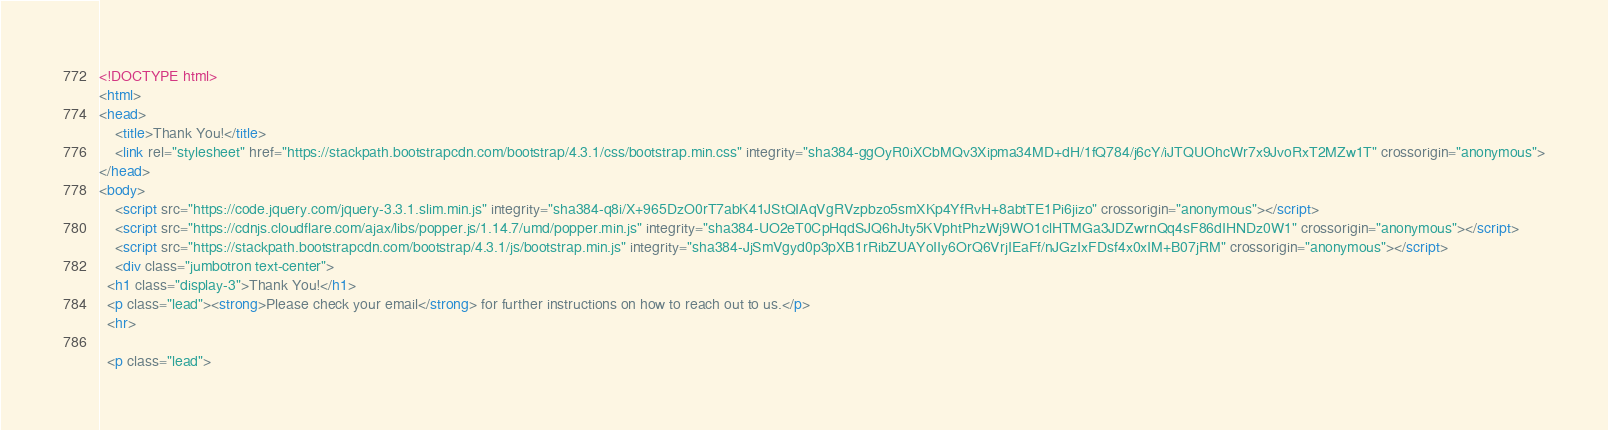<code> <loc_0><loc_0><loc_500><loc_500><_HTML_><!DOCTYPE html>
<html>
<head>
	<title>Thank You!</title>
	<link rel="stylesheet" href="https://stackpath.bootstrapcdn.com/bootstrap/4.3.1/css/bootstrap.min.css" integrity="sha384-ggOyR0iXCbMQv3Xipma34MD+dH/1fQ784/j6cY/iJTQUOhcWr7x9JvoRxT2MZw1T" crossorigin="anonymous">
</head>
<body>
	<script src="https://code.jquery.com/jquery-3.3.1.slim.min.js" integrity="sha384-q8i/X+965DzO0rT7abK41JStQIAqVgRVzpbzo5smXKp4YfRvH+8abtTE1Pi6jizo" crossorigin="anonymous"></script>
	<script src="https://cdnjs.cloudflare.com/ajax/libs/popper.js/1.14.7/umd/popper.min.js" integrity="sha384-UO2eT0CpHqdSJQ6hJty5KVphtPhzWj9WO1clHTMGa3JDZwrnQq4sF86dIHNDz0W1" crossorigin="anonymous"></script>
	<script src="https://stackpath.bootstrapcdn.com/bootstrap/4.3.1/js/bootstrap.min.js" integrity="sha384-JjSmVgyd0p3pXB1rRibZUAYoIIy6OrQ6VrjIEaFf/nJGzIxFDsf4x0xIM+B07jRM" crossorigin="anonymous"></script>
	<div class="jumbotron text-center">
  <h1 class="display-3">Thank You!</h1>
  <p class="lead"><strong>Please check your email</strong> for further instructions on how to reach out to us.</p>
  <hr>
 
  <p class="lead"></code> 